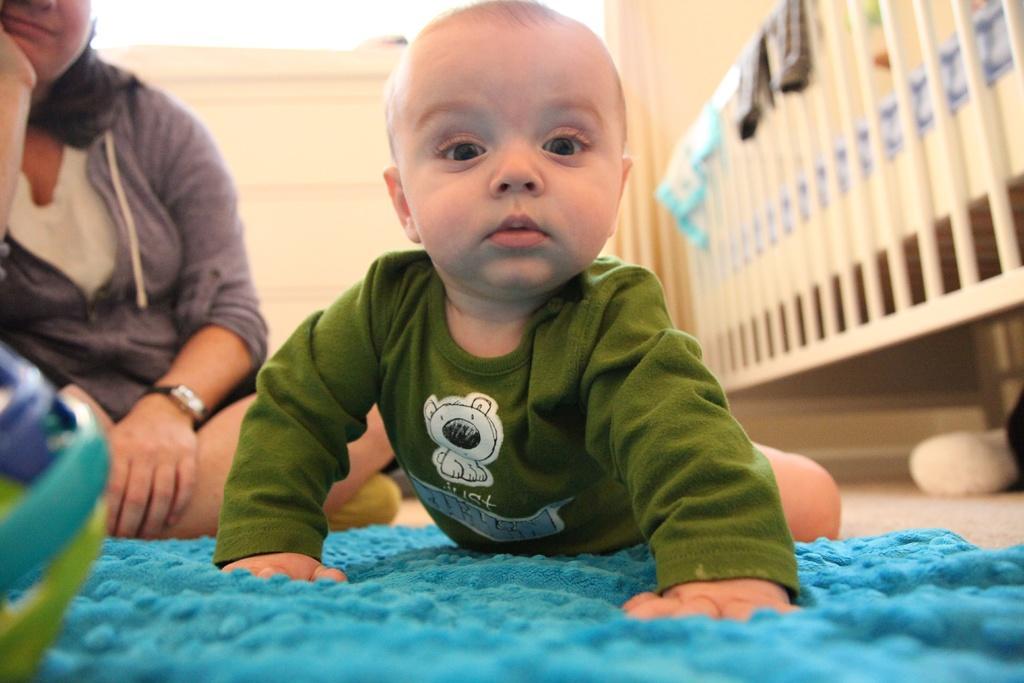Please provide a concise description of this image. In this image we can see a boy on the mat which is on the floor. We can also see a woman. In the background we can see the clothes on the bed. 